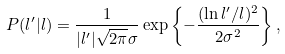<formula> <loc_0><loc_0><loc_500><loc_500>P ( l ^ { \prime } | l ) = \frac { 1 } { | l ^ { \prime } | \sqrt { 2 \pi } \sigma } \exp \left \{ - \frac { ( \ln l ^ { \prime } / l ) ^ { 2 } } { 2 \sigma ^ { 2 } } \right \} ,</formula> 